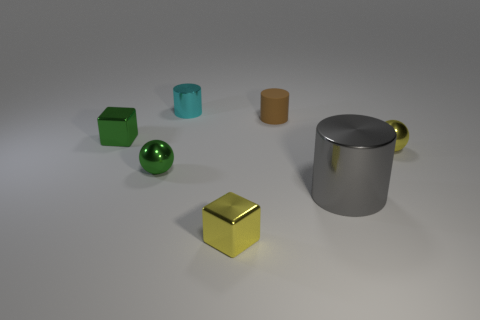Is the number of tiny green shiny blocks greater than the number of large red shiny things?
Offer a very short reply. Yes. What material is the cyan object that is the same size as the rubber cylinder?
Give a very brief answer. Metal. There is a cube that is right of the green block; is it the same size as the tiny cyan shiny cylinder?
Your response must be concise. Yes. How many cylinders are either tiny things or small green things?
Provide a succinct answer. 2. There is a cylinder in front of the yellow ball; what is it made of?
Your answer should be very brief. Metal. Are there fewer green metal spheres than small spheres?
Ensure brevity in your answer.  Yes. How big is the cylinder that is both on the right side of the tiny cyan metallic object and behind the gray shiny cylinder?
Make the answer very short. Small. There is a gray cylinder that is to the right of the metal sphere left of the metal cylinder behind the tiny green shiny block; what size is it?
Your answer should be very brief. Large. What number of other things are the same color as the small rubber cylinder?
Give a very brief answer. 0. Do the small shiny object right of the brown rubber object and the rubber cylinder have the same color?
Provide a short and direct response. No. 